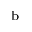Convert formula to latex. <formula><loc_0><loc_0><loc_500><loc_500>^ { b }</formula> 